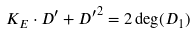Convert formula to latex. <formula><loc_0><loc_0><loc_500><loc_500>K _ { E } \cdot D ^ { \prime } + { D ^ { \prime } } ^ { 2 } = 2 \deg ( D _ { 1 } )</formula> 